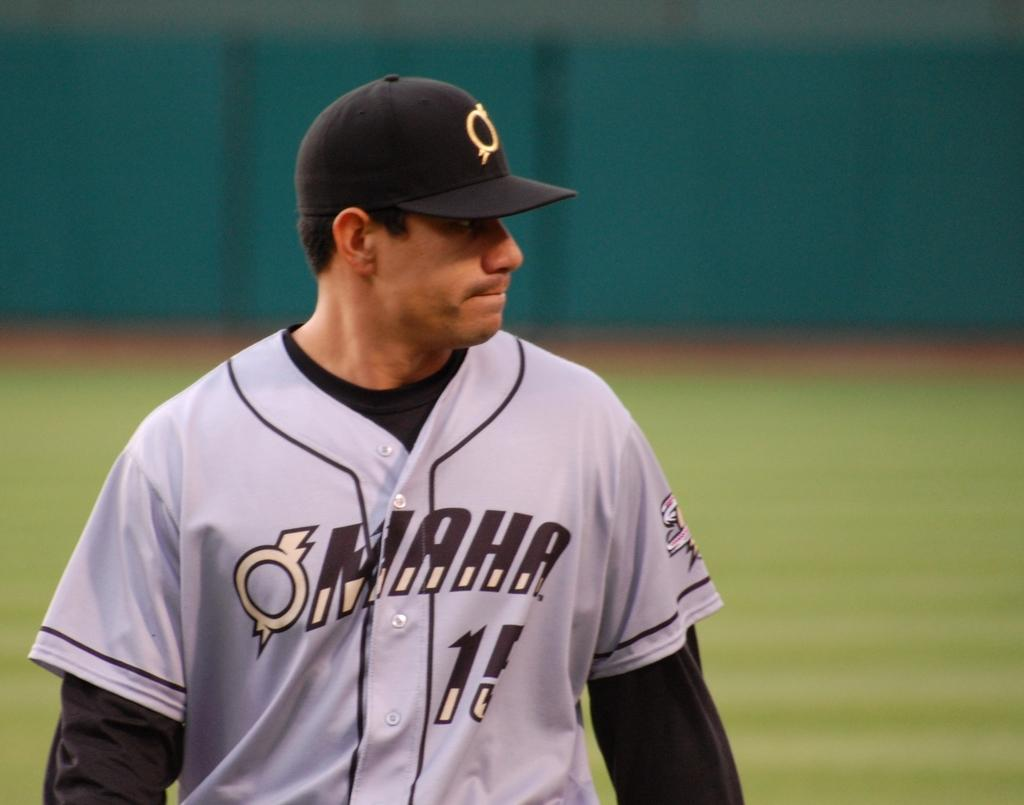<image>
Summarize the visual content of the image. Baseball player in a gray uniform with MAHA on the front of his jersey. 